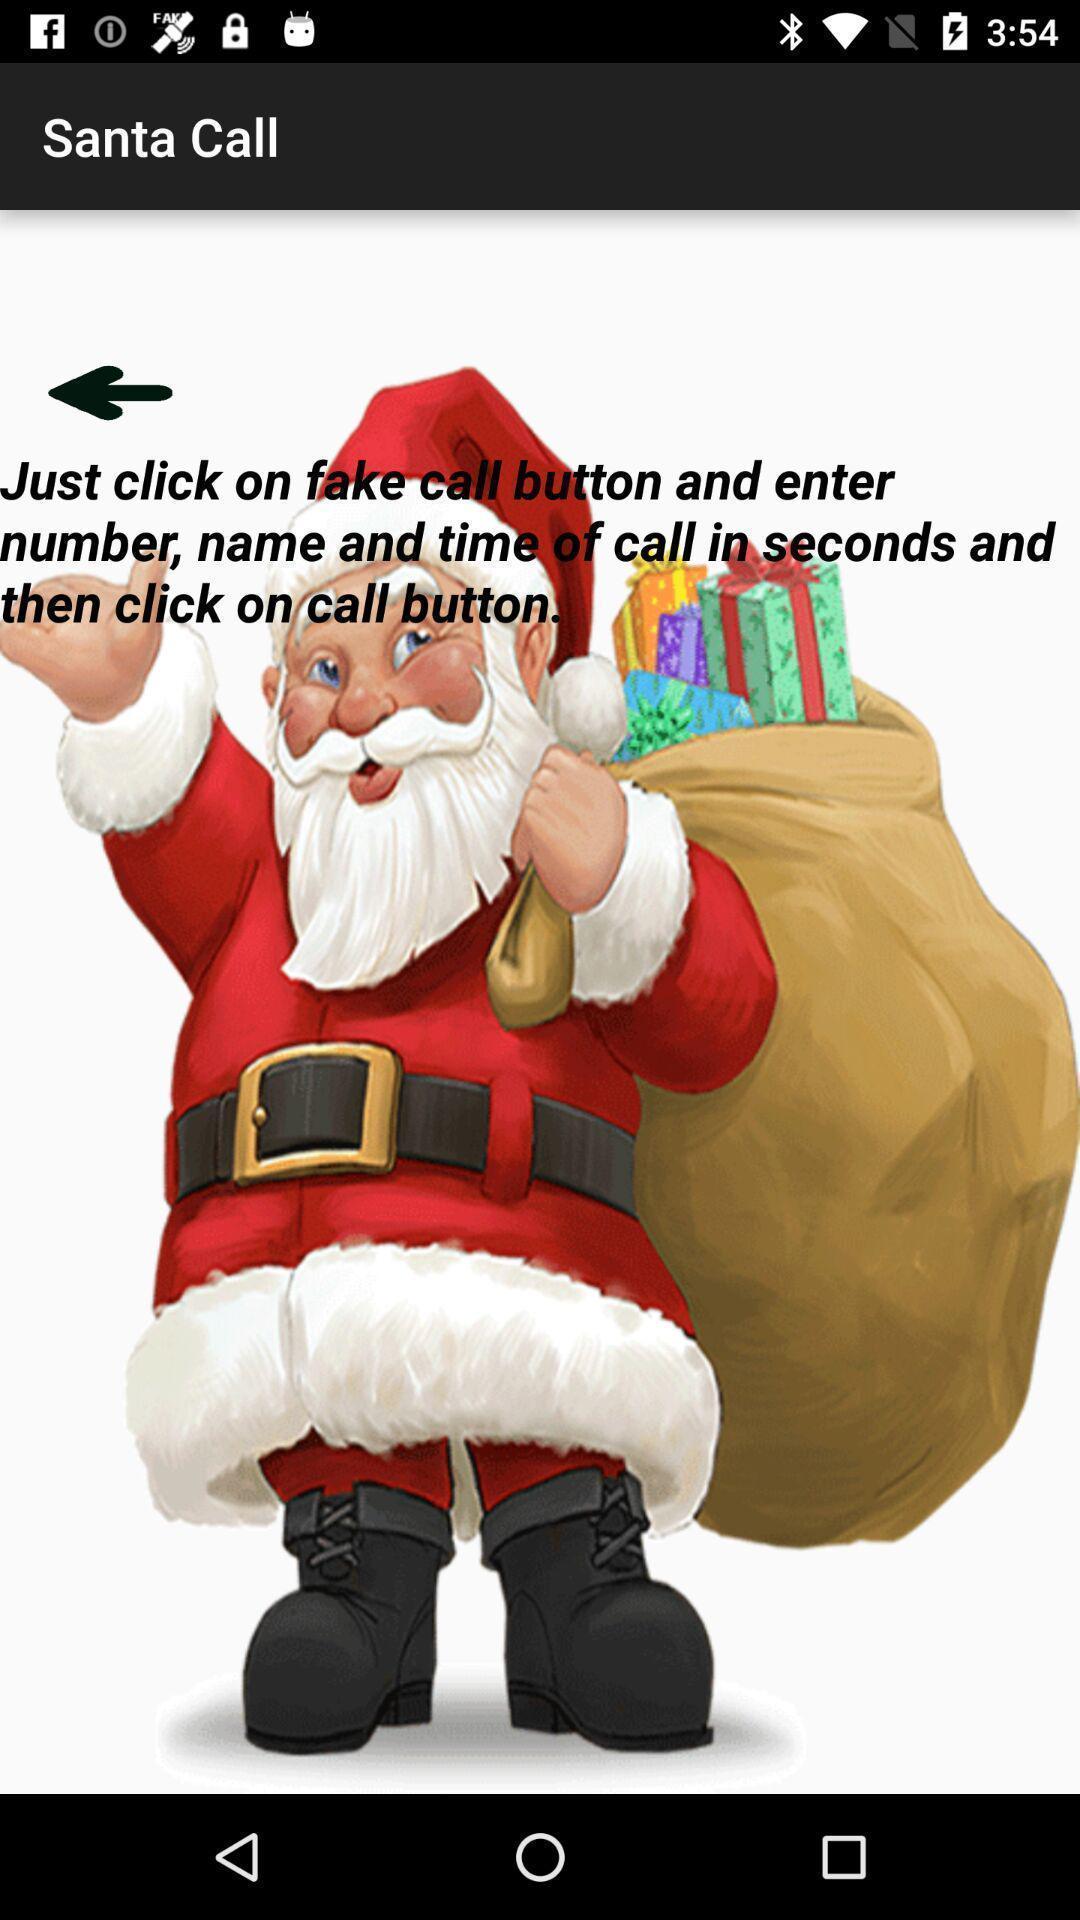Provide a textual representation of this image. Screen displaying page. 